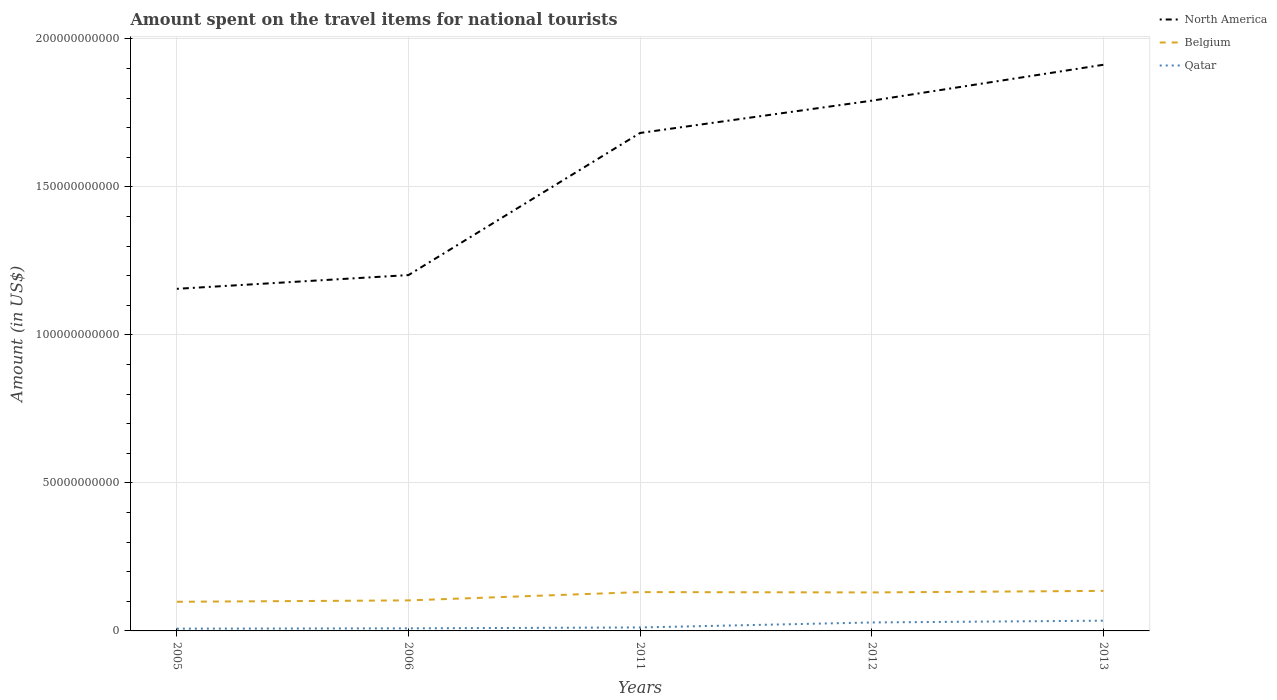Does the line corresponding to North America intersect with the line corresponding to Belgium?
Ensure brevity in your answer.  No. Across all years, what is the maximum amount spent on the travel items for national tourists in Belgium?
Provide a short and direct response. 9.84e+09. What is the total amount spent on the travel items for national tourists in Qatar in the graph?
Keep it short and to the point. -5.99e+08. What is the difference between the highest and the second highest amount spent on the travel items for national tourists in Belgium?
Ensure brevity in your answer.  3.68e+09. What is the difference between the highest and the lowest amount spent on the travel items for national tourists in Qatar?
Your answer should be very brief. 2. Are the values on the major ticks of Y-axis written in scientific E-notation?
Keep it short and to the point. No. Where does the legend appear in the graph?
Offer a very short reply. Top right. What is the title of the graph?
Give a very brief answer. Amount spent on the travel items for national tourists. Does "Albania" appear as one of the legend labels in the graph?
Provide a short and direct response. No. What is the Amount (in US$) in North America in 2005?
Your answer should be very brief. 1.16e+11. What is the Amount (in US$) of Belgium in 2005?
Your response must be concise. 9.84e+09. What is the Amount (in US$) in Qatar in 2005?
Provide a short and direct response. 7.60e+08. What is the Amount (in US$) in North America in 2006?
Give a very brief answer. 1.20e+11. What is the Amount (in US$) of Belgium in 2006?
Keep it short and to the point. 1.03e+1. What is the Amount (in US$) in Qatar in 2006?
Give a very brief answer. 8.74e+08. What is the Amount (in US$) in North America in 2011?
Offer a very short reply. 1.68e+11. What is the Amount (in US$) of Belgium in 2011?
Offer a very short reply. 1.31e+1. What is the Amount (in US$) of Qatar in 2011?
Your answer should be very brief. 1.17e+09. What is the Amount (in US$) in North America in 2012?
Give a very brief answer. 1.79e+11. What is the Amount (in US$) of Belgium in 2012?
Provide a succinct answer. 1.30e+1. What is the Amount (in US$) in Qatar in 2012?
Your response must be concise. 2.86e+09. What is the Amount (in US$) of North America in 2013?
Your response must be concise. 1.91e+11. What is the Amount (in US$) in Belgium in 2013?
Offer a terse response. 1.35e+1. What is the Amount (in US$) of Qatar in 2013?
Make the answer very short. 3.46e+09. Across all years, what is the maximum Amount (in US$) of North America?
Your answer should be very brief. 1.91e+11. Across all years, what is the maximum Amount (in US$) of Belgium?
Provide a succinct answer. 1.35e+1. Across all years, what is the maximum Amount (in US$) of Qatar?
Provide a succinct answer. 3.46e+09. Across all years, what is the minimum Amount (in US$) of North America?
Your answer should be compact. 1.16e+11. Across all years, what is the minimum Amount (in US$) in Belgium?
Provide a short and direct response. 9.84e+09. Across all years, what is the minimum Amount (in US$) in Qatar?
Make the answer very short. 7.60e+08. What is the total Amount (in US$) of North America in the graph?
Offer a very short reply. 7.74e+11. What is the total Amount (in US$) of Belgium in the graph?
Your answer should be very brief. 5.98e+1. What is the total Amount (in US$) in Qatar in the graph?
Offer a very short reply. 9.12e+09. What is the difference between the Amount (in US$) of North America in 2005 and that in 2006?
Make the answer very short. -4.64e+09. What is the difference between the Amount (in US$) in Belgium in 2005 and that in 2006?
Make the answer very short. -4.66e+08. What is the difference between the Amount (in US$) of Qatar in 2005 and that in 2006?
Provide a short and direct response. -1.14e+08. What is the difference between the Amount (in US$) in North America in 2005 and that in 2011?
Your response must be concise. -5.26e+1. What is the difference between the Amount (in US$) of Belgium in 2005 and that in 2011?
Your answer should be compact. -3.27e+09. What is the difference between the Amount (in US$) of Qatar in 2005 and that in 2011?
Keep it short and to the point. -4.10e+08. What is the difference between the Amount (in US$) in North America in 2005 and that in 2012?
Ensure brevity in your answer.  -6.35e+1. What is the difference between the Amount (in US$) in Belgium in 2005 and that in 2012?
Offer a terse response. -3.16e+09. What is the difference between the Amount (in US$) in Qatar in 2005 and that in 2012?
Provide a succinct answer. -2.10e+09. What is the difference between the Amount (in US$) of North America in 2005 and that in 2013?
Provide a succinct answer. -7.57e+1. What is the difference between the Amount (in US$) in Belgium in 2005 and that in 2013?
Your answer should be very brief. -3.68e+09. What is the difference between the Amount (in US$) of Qatar in 2005 and that in 2013?
Make the answer very short. -2.70e+09. What is the difference between the Amount (in US$) in North America in 2006 and that in 2011?
Provide a short and direct response. -4.80e+1. What is the difference between the Amount (in US$) in Belgium in 2006 and that in 2011?
Ensure brevity in your answer.  -2.80e+09. What is the difference between the Amount (in US$) of Qatar in 2006 and that in 2011?
Keep it short and to the point. -2.96e+08. What is the difference between the Amount (in US$) in North America in 2006 and that in 2012?
Offer a very short reply. -5.89e+1. What is the difference between the Amount (in US$) in Belgium in 2006 and that in 2012?
Provide a succinct answer. -2.69e+09. What is the difference between the Amount (in US$) in Qatar in 2006 and that in 2012?
Provide a succinct answer. -1.98e+09. What is the difference between the Amount (in US$) in North America in 2006 and that in 2013?
Your answer should be compact. -7.10e+1. What is the difference between the Amount (in US$) in Belgium in 2006 and that in 2013?
Provide a short and direct response. -3.21e+09. What is the difference between the Amount (in US$) in Qatar in 2006 and that in 2013?
Your answer should be compact. -2.58e+09. What is the difference between the Amount (in US$) in North America in 2011 and that in 2012?
Provide a short and direct response. -1.09e+1. What is the difference between the Amount (in US$) of Belgium in 2011 and that in 2012?
Keep it short and to the point. 1.10e+08. What is the difference between the Amount (in US$) in Qatar in 2011 and that in 2012?
Offer a very short reply. -1.69e+09. What is the difference between the Amount (in US$) in North America in 2011 and that in 2013?
Keep it short and to the point. -2.30e+1. What is the difference between the Amount (in US$) of Belgium in 2011 and that in 2013?
Provide a succinct answer. -4.13e+08. What is the difference between the Amount (in US$) of Qatar in 2011 and that in 2013?
Ensure brevity in your answer.  -2.29e+09. What is the difference between the Amount (in US$) of North America in 2012 and that in 2013?
Provide a short and direct response. -1.21e+1. What is the difference between the Amount (in US$) in Belgium in 2012 and that in 2013?
Offer a very short reply. -5.23e+08. What is the difference between the Amount (in US$) of Qatar in 2012 and that in 2013?
Make the answer very short. -5.99e+08. What is the difference between the Amount (in US$) in North America in 2005 and the Amount (in US$) in Belgium in 2006?
Keep it short and to the point. 1.05e+11. What is the difference between the Amount (in US$) of North America in 2005 and the Amount (in US$) of Qatar in 2006?
Keep it short and to the point. 1.15e+11. What is the difference between the Amount (in US$) in Belgium in 2005 and the Amount (in US$) in Qatar in 2006?
Your response must be concise. 8.97e+09. What is the difference between the Amount (in US$) of North America in 2005 and the Amount (in US$) of Belgium in 2011?
Make the answer very short. 1.02e+11. What is the difference between the Amount (in US$) in North America in 2005 and the Amount (in US$) in Qatar in 2011?
Offer a very short reply. 1.14e+11. What is the difference between the Amount (in US$) in Belgium in 2005 and the Amount (in US$) in Qatar in 2011?
Provide a succinct answer. 8.68e+09. What is the difference between the Amount (in US$) of North America in 2005 and the Amount (in US$) of Belgium in 2012?
Offer a terse response. 1.03e+11. What is the difference between the Amount (in US$) of North America in 2005 and the Amount (in US$) of Qatar in 2012?
Your answer should be very brief. 1.13e+11. What is the difference between the Amount (in US$) in Belgium in 2005 and the Amount (in US$) in Qatar in 2012?
Offer a terse response. 6.99e+09. What is the difference between the Amount (in US$) in North America in 2005 and the Amount (in US$) in Belgium in 2013?
Your answer should be compact. 1.02e+11. What is the difference between the Amount (in US$) of North America in 2005 and the Amount (in US$) of Qatar in 2013?
Offer a terse response. 1.12e+11. What is the difference between the Amount (in US$) in Belgium in 2005 and the Amount (in US$) in Qatar in 2013?
Provide a succinct answer. 6.39e+09. What is the difference between the Amount (in US$) of North America in 2006 and the Amount (in US$) of Belgium in 2011?
Your answer should be compact. 1.07e+11. What is the difference between the Amount (in US$) in North America in 2006 and the Amount (in US$) in Qatar in 2011?
Your answer should be very brief. 1.19e+11. What is the difference between the Amount (in US$) of Belgium in 2006 and the Amount (in US$) of Qatar in 2011?
Provide a succinct answer. 9.14e+09. What is the difference between the Amount (in US$) in North America in 2006 and the Amount (in US$) in Belgium in 2012?
Your answer should be very brief. 1.07e+11. What is the difference between the Amount (in US$) in North America in 2006 and the Amount (in US$) in Qatar in 2012?
Offer a terse response. 1.17e+11. What is the difference between the Amount (in US$) of Belgium in 2006 and the Amount (in US$) of Qatar in 2012?
Give a very brief answer. 7.45e+09. What is the difference between the Amount (in US$) of North America in 2006 and the Amount (in US$) of Belgium in 2013?
Ensure brevity in your answer.  1.07e+11. What is the difference between the Amount (in US$) of North America in 2006 and the Amount (in US$) of Qatar in 2013?
Offer a terse response. 1.17e+11. What is the difference between the Amount (in US$) of Belgium in 2006 and the Amount (in US$) of Qatar in 2013?
Make the answer very short. 6.86e+09. What is the difference between the Amount (in US$) of North America in 2011 and the Amount (in US$) of Belgium in 2012?
Your answer should be very brief. 1.55e+11. What is the difference between the Amount (in US$) of North America in 2011 and the Amount (in US$) of Qatar in 2012?
Give a very brief answer. 1.65e+11. What is the difference between the Amount (in US$) in Belgium in 2011 and the Amount (in US$) in Qatar in 2012?
Your answer should be compact. 1.03e+1. What is the difference between the Amount (in US$) of North America in 2011 and the Amount (in US$) of Belgium in 2013?
Offer a terse response. 1.55e+11. What is the difference between the Amount (in US$) in North America in 2011 and the Amount (in US$) in Qatar in 2013?
Make the answer very short. 1.65e+11. What is the difference between the Amount (in US$) in Belgium in 2011 and the Amount (in US$) in Qatar in 2013?
Ensure brevity in your answer.  9.66e+09. What is the difference between the Amount (in US$) in North America in 2012 and the Amount (in US$) in Belgium in 2013?
Your response must be concise. 1.66e+11. What is the difference between the Amount (in US$) of North America in 2012 and the Amount (in US$) of Qatar in 2013?
Ensure brevity in your answer.  1.76e+11. What is the difference between the Amount (in US$) in Belgium in 2012 and the Amount (in US$) in Qatar in 2013?
Make the answer very short. 9.54e+09. What is the average Amount (in US$) of North America per year?
Keep it short and to the point. 1.55e+11. What is the average Amount (in US$) in Belgium per year?
Your answer should be compact. 1.20e+1. What is the average Amount (in US$) of Qatar per year?
Your response must be concise. 1.82e+09. In the year 2005, what is the difference between the Amount (in US$) of North America and Amount (in US$) of Belgium?
Make the answer very short. 1.06e+11. In the year 2005, what is the difference between the Amount (in US$) of North America and Amount (in US$) of Qatar?
Keep it short and to the point. 1.15e+11. In the year 2005, what is the difference between the Amount (in US$) in Belgium and Amount (in US$) in Qatar?
Ensure brevity in your answer.  9.08e+09. In the year 2006, what is the difference between the Amount (in US$) of North America and Amount (in US$) of Belgium?
Provide a succinct answer. 1.10e+11. In the year 2006, what is the difference between the Amount (in US$) in North America and Amount (in US$) in Qatar?
Ensure brevity in your answer.  1.19e+11. In the year 2006, what is the difference between the Amount (in US$) of Belgium and Amount (in US$) of Qatar?
Keep it short and to the point. 9.44e+09. In the year 2011, what is the difference between the Amount (in US$) in North America and Amount (in US$) in Belgium?
Ensure brevity in your answer.  1.55e+11. In the year 2011, what is the difference between the Amount (in US$) of North America and Amount (in US$) of Qatar?
Make the answer very short. 1.67e+11. In the year 2011, what is the difference between the Amount (in US$) of Belgium and Amount (in US$) of Qatar?
Offer a very short reply. 1.19e+1. In the year 2012, what is the difference between the Amount (in US$) in North America and Amount (in US$) in Belgium?
Ensure brevity in your answer.  1.66e+11. In the year 2012, what is the difference between the Amount (in US$) in North America and Amount (in US$) in Qatar?
Give a very brief answer. 1.76e+11. In the year 2012, what is the difference between the Amount (in US$) of Belgium and Amount (in US$) of Qatar?
Offer a very short reply. 1.01e+1. In the year 2013, what is the difference between the Amount (in US$) of North America and Amount (in US$) of Belgium?
Keep it short and to the point. 1.78e+11. In the year 2013, what is the difference between the Amount (in US$) of North America and Amount (in US$) of Qatar?
Your answer should be compact. 1.88e+11. In the year 2013, what is the difference between the Amount (in US$) of Belgium and Amount (in US$) of Qatar?
Make the answer very short. 1.01e+1. What is the ratio of the Amount (in US$) in North America in 2005 to that in 2006?
Offer a very short reply. 0.96. What is the ratio of the Amount (in US$) in Belgium in 2005 to that in 2006?
Make the answer very short. 0.95. What is the ratio of the Amount (in US$) in Qatar in 2005 to that in 2006?
Offer a terse response. 0.87. What is the ratio of the Amount (in US$) of North America in 2005 to that in 2011?
Give a very brief answer. 0.69. What is the ratio of the Amount (in US$) in Belgium in 2005 to that in 2011?
Provide a succinct answer. 0.75. What is the ratio of the Amount (in US$) in Qatar in 2005 to that in 2011?
Ensure brevity in your answer.  0.65. What is the ratio of the Amount (in US$) in North America in 2005 to that in 2012?
Your answer should be very brief. 0.65. What is the ratio of the Amount (in US$) in Belgium in 2005 to that in 2012?
Your answer should be compact. 0.76. What is the ratio of the Amount (in US$) of Qatar in 2005 to that in 2012?
Keep it short and to the point. 0.27. What is the ratio of the Amount (in US$) in North America in 2005 to that in 2013?
Provide a succinct answer. 0.6. What is the ratio of the Amount (in US$) in Belgium in 2005 to that in 2013?
Offer a terse response. 0.73. What is the ratio of the Amount (in US$) in Qatar in 2005 to that in 2013?
Your answer should be compact. 0.22. What is the ratio of the Amount (in US$) in North America in 2006 to that in 2011?
Offer a terse response. 0.71. What is the ratio of the Amount (in US$) in Belgium in 2006 to that in 2011?
Give a very brief answer. 0.79. What is the ratio of the Amount (in US$) of Qatar in 2006 to that in 2011?
Provide a succinct answer. 0.75. What is the ratio of the Amount (in US$) in North America in 2006 to that in 2012?
Your answer should be compact. 0.67. What is the ratio of the Amount (in US$) in Belgium in 2006 to that in 2012?
Your response must be concise. 0.79. What is the ratio of the Amount (in US$) in Qatar in 2006 to that in 2012?
Provide a succinct answer. 0.31. What is the ratio of the Amount (in US$) of North America in 2006 to that in 2013?
Provide a short and direct response. 0.63. What is the ratio of the Amount (in US$) of Belgium in 2006 to that in 2013?
Ensure brevity in your answer.  0.76. What is the ratio of the Amount (in US$) in Qatar in 2006 to that in 2013?
Your answer should be compact. 0.25. What is the ratio of the Amount (in US$) of North America in 2011 to that in 2012?
Your answer should be very brief. 0.94. What is the ratio of the Amount (in US$) of Belgium in 2011 to that in 2012?
Give a very brief answer. 1.01. What is the ratio of the Amount (in US$) of Qatar in 2011 to that in 2012?
Make the answer very short. 0.41. What is the ratio of the Amount (in US$) in North America in 2011 to that in 2013?
Provide a short and direct response. 0.88. What is the ratio of the Amount (in US$) of Belgium in 2011 to that in 2013?
Provide a succinct answer. 0.97. What is the ratio of the Amount (in US$) in Qatar in 2011 to that in 2013?
Your response must be concise. 0.34. What is the ratio of the Amount (in US$) of North America in 2012 to that in 2013?
Give a very brief answer. 0.94. What is the ratio of the Amount (in US$) in Belgium in 2012 to that in 2013?
Your response must be concise. 0.96. What is the ratio of the Amount (in US$) of Qatar in 2012 to that in 2013?
Your answer should be compact. 0.83. What is the difference between the highest and the second highest Amount (in US$) of North America?
Make the answer very short. 1.21e+1. What is the difference between the highest and the second highest Amount (in US$) in Belgium?
Provide a short and direct response. 4.13e+08. What is the difference between the highest and the second highest Amount (in US$) in Qatar?
Keep it short and to the point. 5.99e+08. What is the difference between the highest and the lowest Amount (in US$) of North America?
Your answer should be very brief. 7.57e+1. What is the difference between the highest and the lowest Amount (in US$) in Belgium?
Offer a very short reply. 3.68e+09. What is the difference between the highest and the lowest Amount (in US$) in Qatar?
Keep it short and to the point. 2.70e+09. 